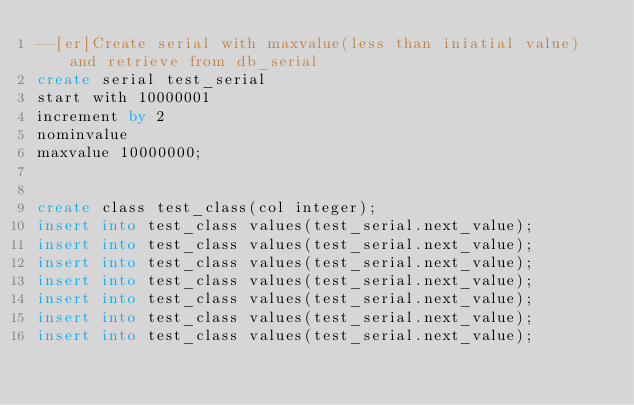<code> <loc_0><loc_0><loc_500><loc_500><_SQL_>--[er]Create serial with maxvalue(less than iniatial value) and retrieve from db_serial
create serial test_serial
start with 10000001
increment by 2
nominvalue
maxvalue 10000000;


create class test_class(col integer);
insert into test_class values(test_serial.next_value);
insert into test_class values(test_serial.next_value);
insert into test_class values(test_serial.next_value);
insert into test_class values(test_serial.next_value);
insert into test_class values(test_serial.next_value);
insert into test_class values(test_serial.next_value);
insert into test_class values(test_serial.next_value);</code> 